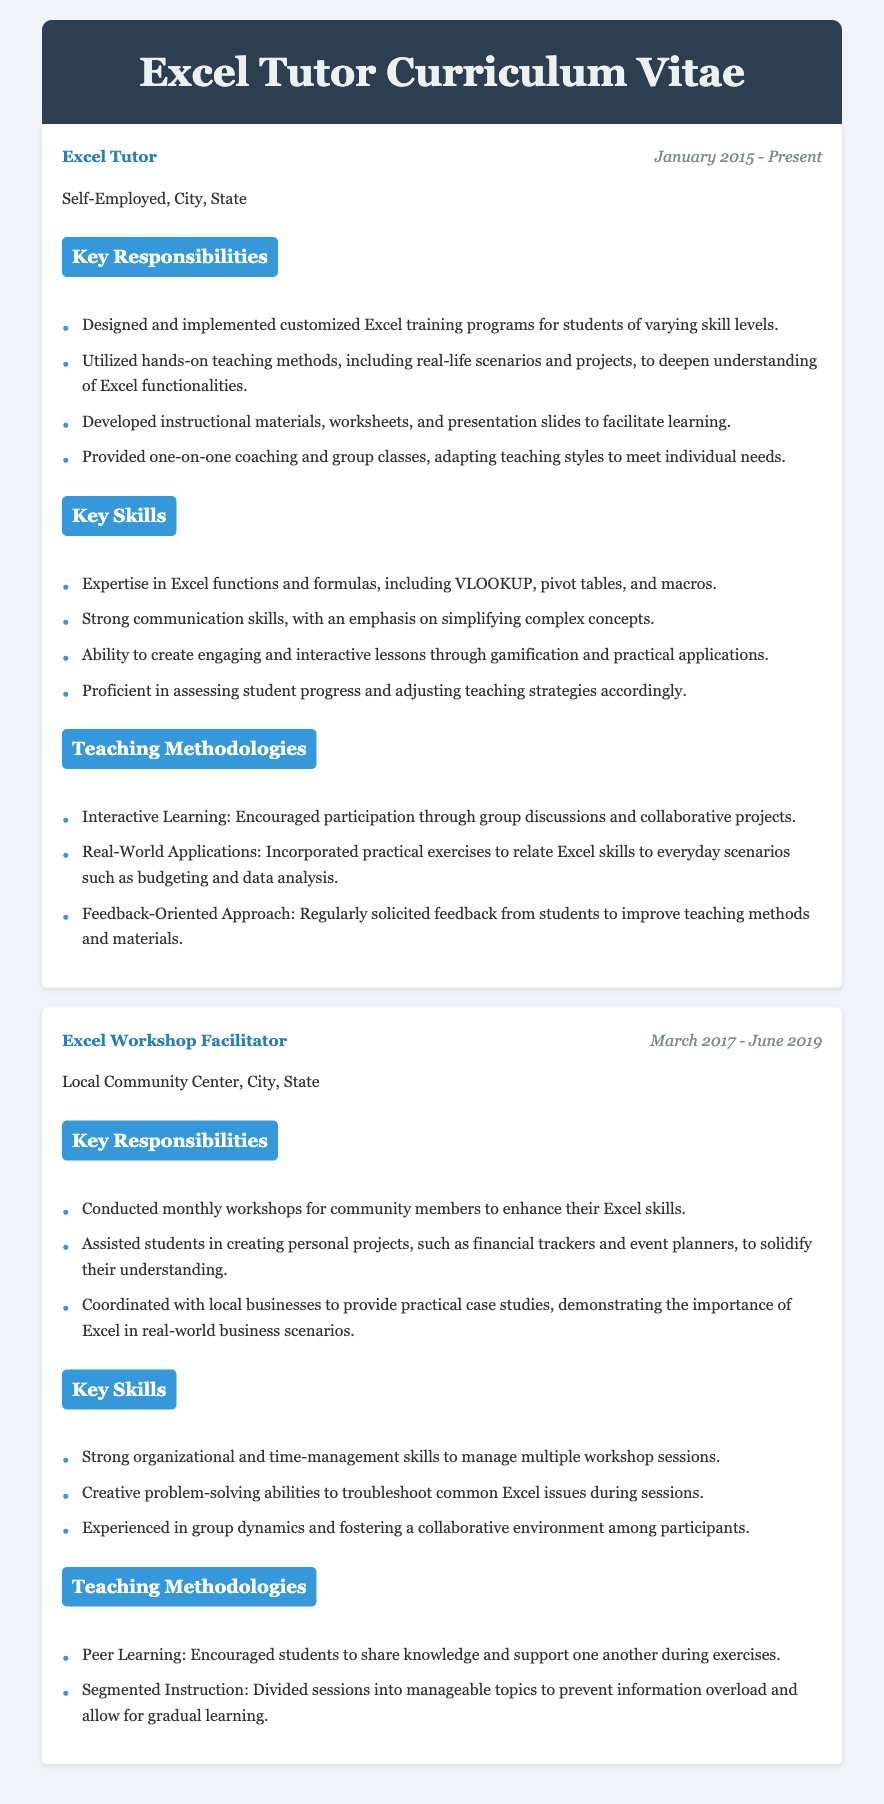What is the job title of the self-employed position? The document lists "Excel Tutor" as the job title of the self-employed position.
Answer: Excel Tutor What is the time span of the Excel Tutor role? The duration for the Excel Tutor role is provided in the document as January 2015 to Present.
Answer: January 2015 - Present What key methodology involves encouraging participation through group discussions? The document mentions "Interactive Learning" as a key methodology that encourages participation.
Answer: Interactive Learning What skill emphasizes simplifying complex concepts? "Strong communication skills" highlights the ability to simplify complex concepts.
Answer: Strong communication skills What organization conducted Excel workshops between March 2017 and June 2019? The document states that the local community center was responsible for the workshops during that time.
Answer: Local Community Center How long was the role of Excel Workshop Facilitator? The time span listed for the Excel Workshop Facilitator role is from March 2017 to June 2019, a duration of 2 years and 3 months.
Answer: 2 years and 3 months What teaching method is highlighted for its role in preventing information overload? "Segmented Instruction" is the teaching method that helps prevent information overload.
Answer: Segmented Instruction Which skill involves managing multiple workshop sessions? The document specifies "Strong organizational and time-management skills" for managing multiple sessions.
Answer: Strong organizational and time-management skills What was a key responsibility of the Excel Tutor? The key responsibility of the Excel Tutor included designing and implementing customized Excel training programs.
Answer: Designing and implementing customized Excel training programs 